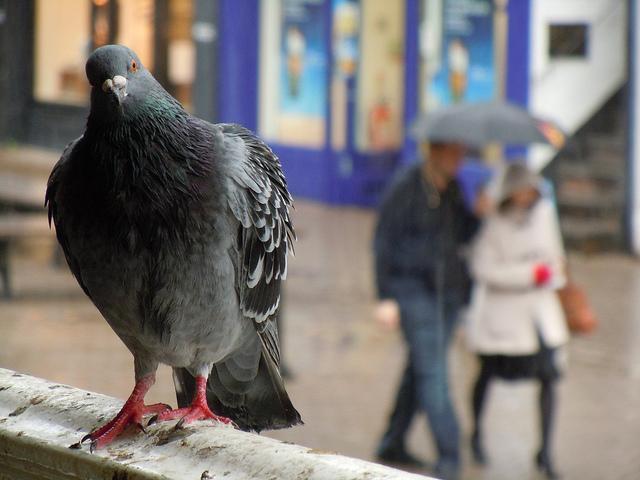Is the statement "The umbrella is under the bird." accurate regarding the image?
Answer yes or no. No. Is "The umbrella is far away from the bird." an appropriate description for the image?
Answer yes or no. Yes. Does the description: "The bird is on the umbrella." accurately reflect the image?
Answer yes or no. No. Is "The bird is beneath the umbrella." an appropriate description for the image?
Answer yes or no. No. Verify the accuracy of this image caption: "The bird is below the umbrella.".
Answer yes or no. No. Is the given caption "The umbrella is above the bird." fitting for the image?
Answer yes or no. No. 